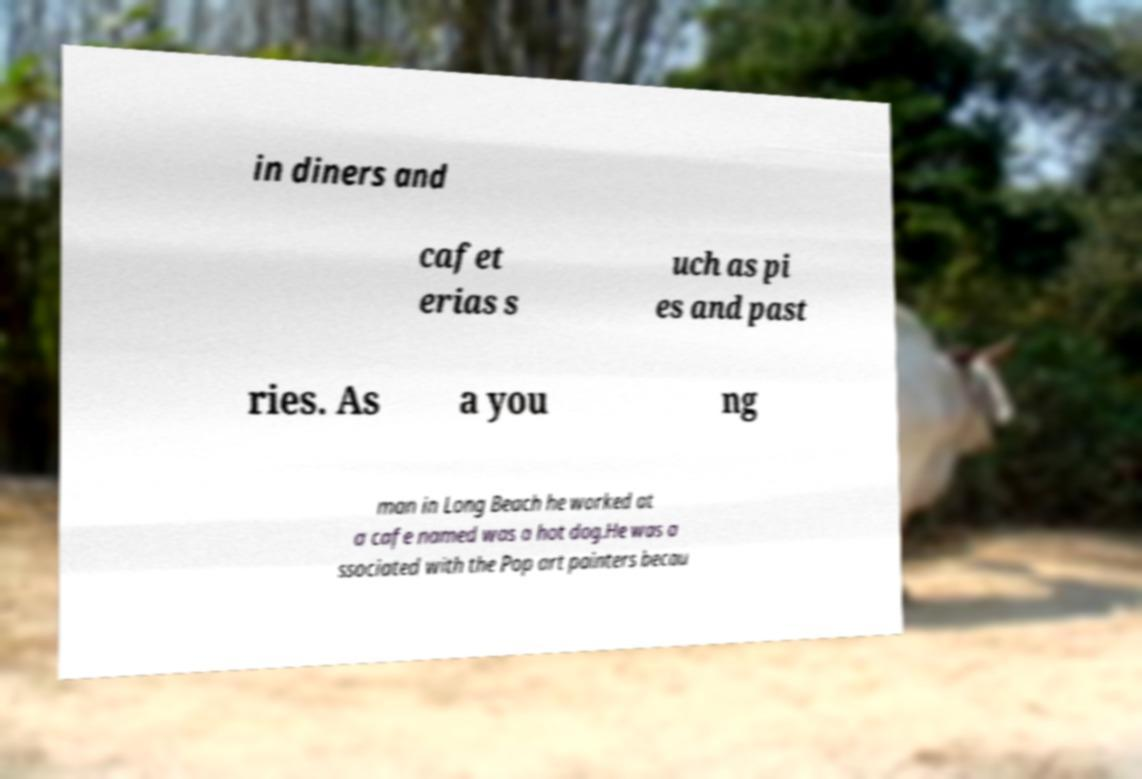Could you assist in decoding the text presented in this image and type it out clearly? in diners and cafet erias s uch as pi es and past ries. As a you ng man in Long Beach he worked at a cafe named was a hot dog.He was a ssociated with the Pop art painters becau 